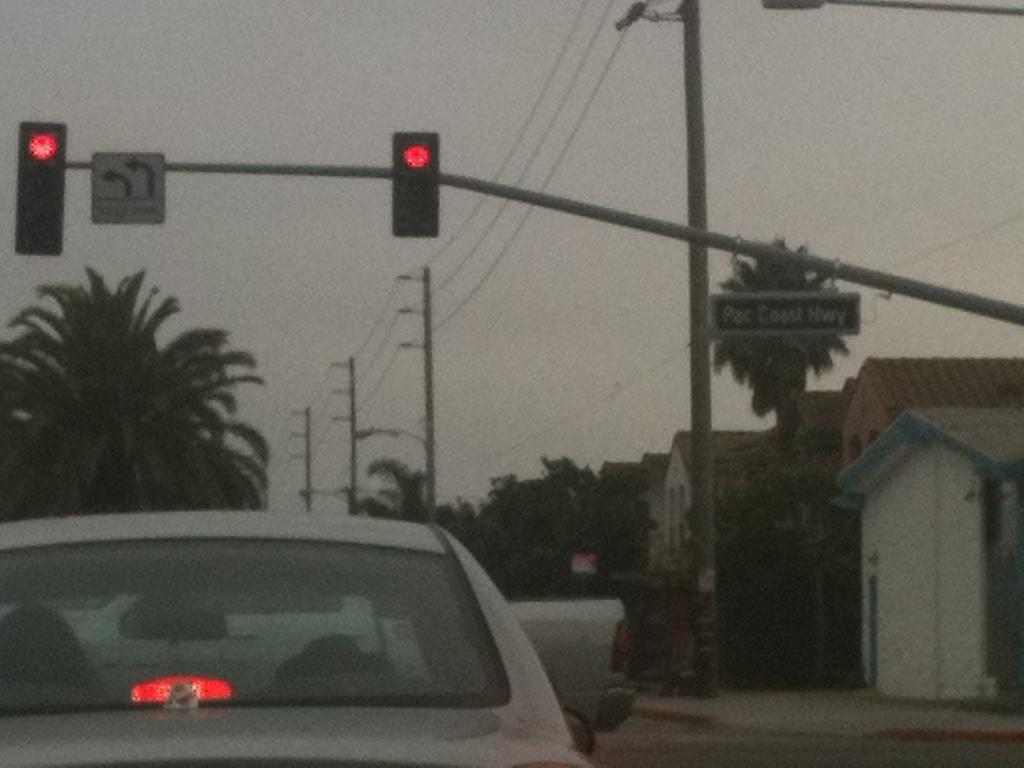<image>
Describe the image concisely. A red traffic light forbiddign cars to cross the Pacific Coast Highway. 